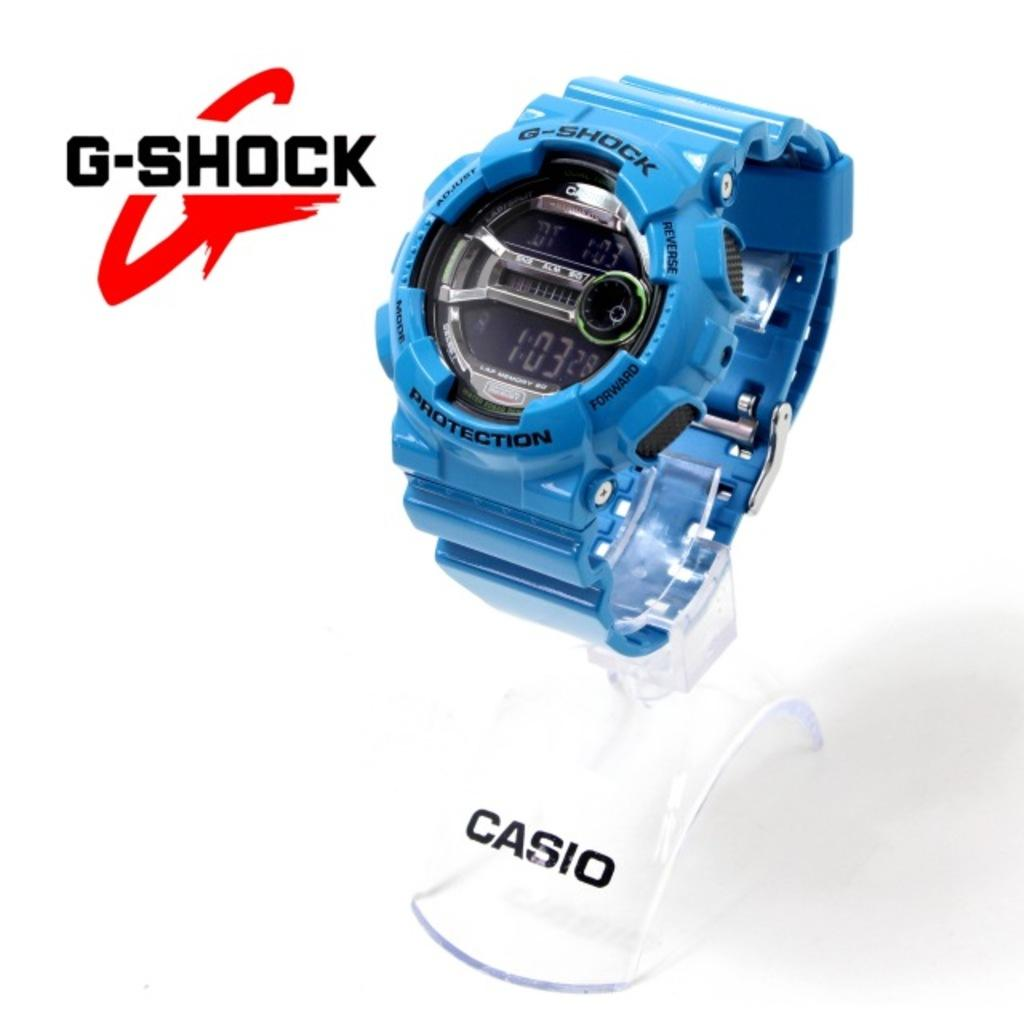Provide a one-sentence caption for the provided image. a casio watch of the g-shock line showing 1:03 as the hour. 